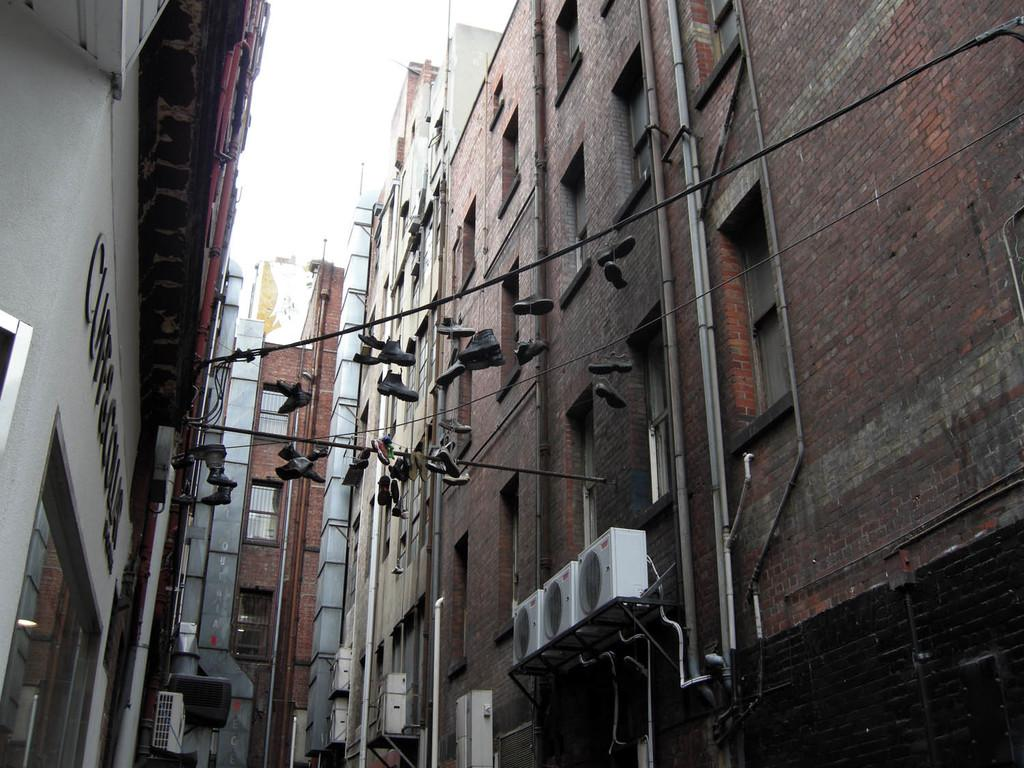What type of structures can be seen in the image? There are buildings in the image. What architectural features are visible on the buildings? Windows are visible in the image. What other objects can be seen in the image? There are pipes and wires in the image. Are there any personal items visible in the image? Yes, there are shoes in the image. What color can be observed among the objects in the image? There are white-colored objects in the image. What type of chin can be seen on the kite in the image? There is no kite present in the image, so it is not possible to observe a chin on a kite. 